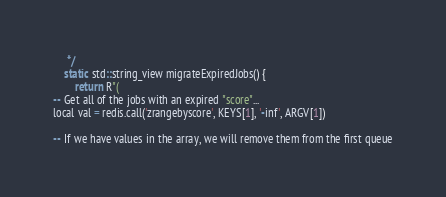Convert code to text. <code><loc_0><loc_0><loc_500><loc_500><_C++_>     */
    static std::string_view migrateExpiredJobs() {
        return R"(
-- Get all of the jobs with an expired "score"...
local val = redis.call('zrangebyscore', KEYS[1], '-inf', ARGV[1])

-- If we have values in the array, we will remove them from the first queue</code> 